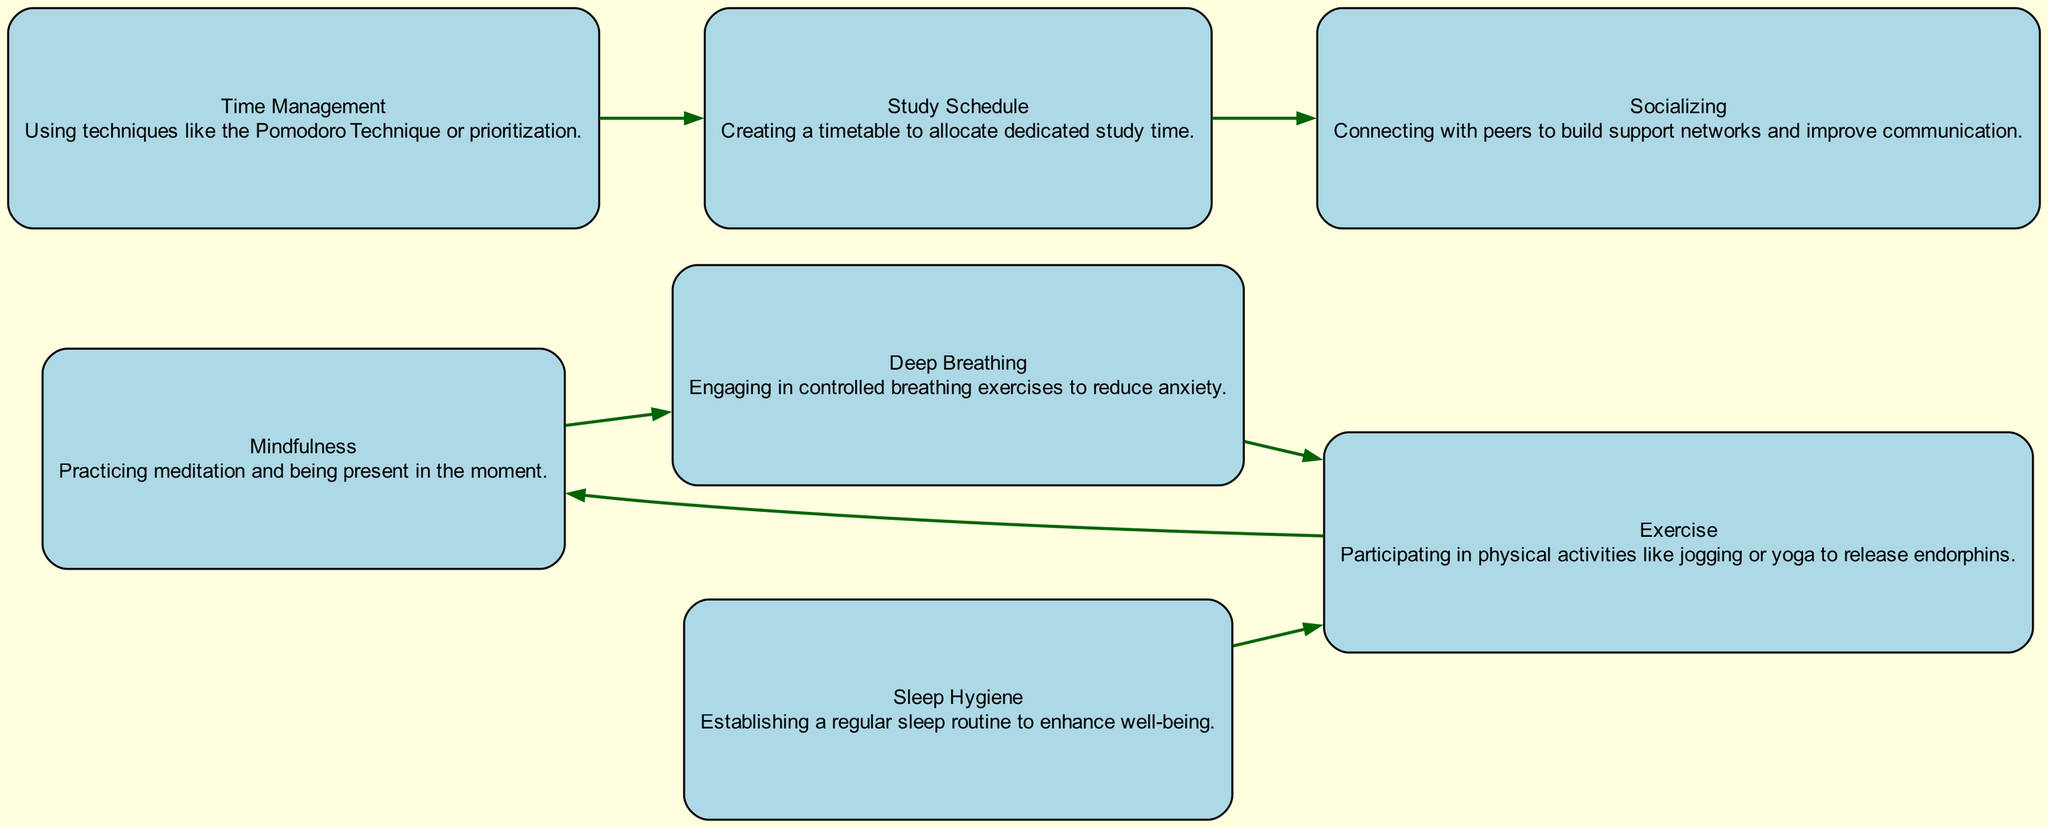What is the total number of nodes in the diagram? The diagram lists six unique nodes: Mindfulness, Deep Breathing, Exercise, Time Management, Study Schedule, Socializing, and Sleep Hygiene. By counting each one, we arrive at a total of six.
Answer: 6 Which method flows into Exercise? There are two methods that flow into Exercise according to the diagram: Sleep Hygiene and Deep Breathing. The edges from these nodes show the connections leading into Exercise.
Answer: Sleep Hygiene, Deep Breathing How many edges connect Mindfulness to other techniques? Mindfulness connects to one method: Deep Breathing. The edge coming from Mindfulness shows a direct relationship with Deep Breathing. Thus, it has one outgoing edge.
Answer: 1 What is the relationship between Time Management and Study Schedule? Time Management directly flows to Study Schedule, as indicated by the directed edge from Time Management to Study Schedule in the diagram.
Answer: flows to Which node has edges flowing into it from two different nodes? The node Exercise has two edges flowing into it: one from Deep Breathing and the other from Sleep Hygiene. This indicates that these two methods are related to Exercise.
Answer: Exercise What technique is used to enhance well-being via a regular routine? The technique that enhances well-being through a regular routine, as indicated in the diagram, is Sleep Hygiene. This refers to establishing a consistent sleep pattern.
Answer: Sleep Hygiene How does socializing relate to the study schedule? The relationship established in the diagram shows that the Study Schedule flows into Socializing, which indicates that having a well-structured study plan can enhance social connections.
Answer: flows to Which technique is described as using methods like the Pomodoro Technique? The technique described as employing methods like the Pomodoro Technique is Time Management. This is explicit in the description of that node within the diagram.
Answer: Time Management 